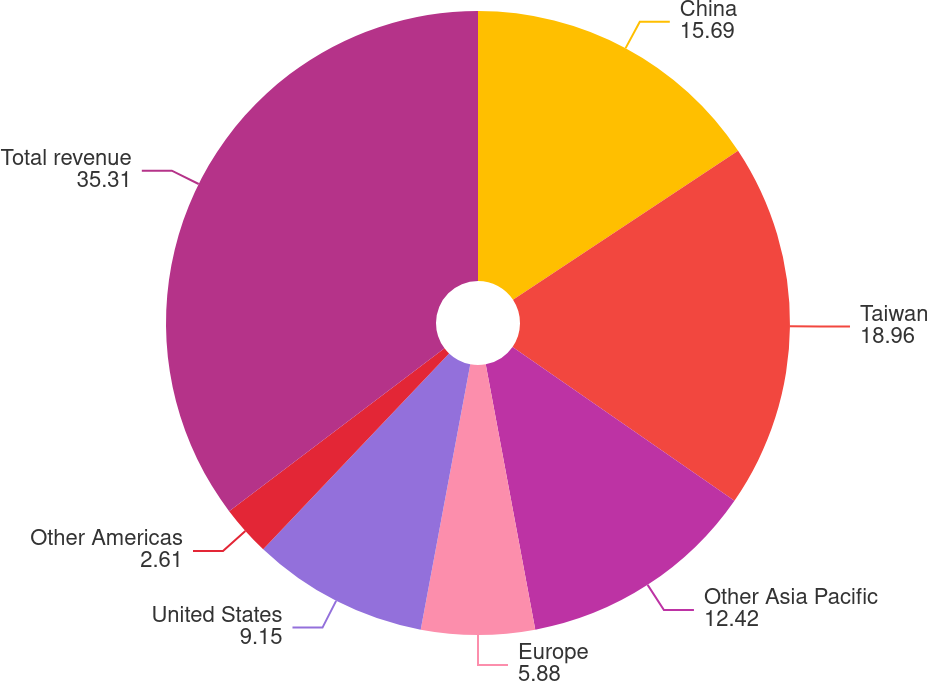<chart> <loc_0><loc_0><loc_500><loc_500><pie_chart><fcel>China<fcel>Taiwan<fcel>Other Asia Pacific<fcel>Europe<fcel>United States<fcel>Other Americas<fcel>Total revenue<nl><fcel>15.69%<fcel>18.96%<fcel>12.42%<fcel>5.88%<fcel>9.15%<fcel>2.61%<fcel>35.31%<nl></chart> 